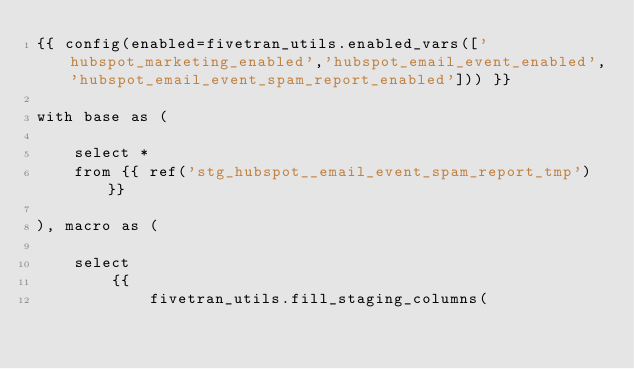Convert code to text. <code><loc_0><loc_0><loc_500><loc_500><_SQL_>{{ config(enabled=fivetran_utils.enabled_vars(['hubspot_marketing_enabled','hubspot_email_event_enabled','hubspot_email_event_spam_report_enabled'])) }}

with base as (

    select *
    from {{ ref('stg_hubspot__email_event_spam_report_tmp') }}

), macro as (

    select
        {{
            fivetran_utils.fill_staging_columns(</code> 